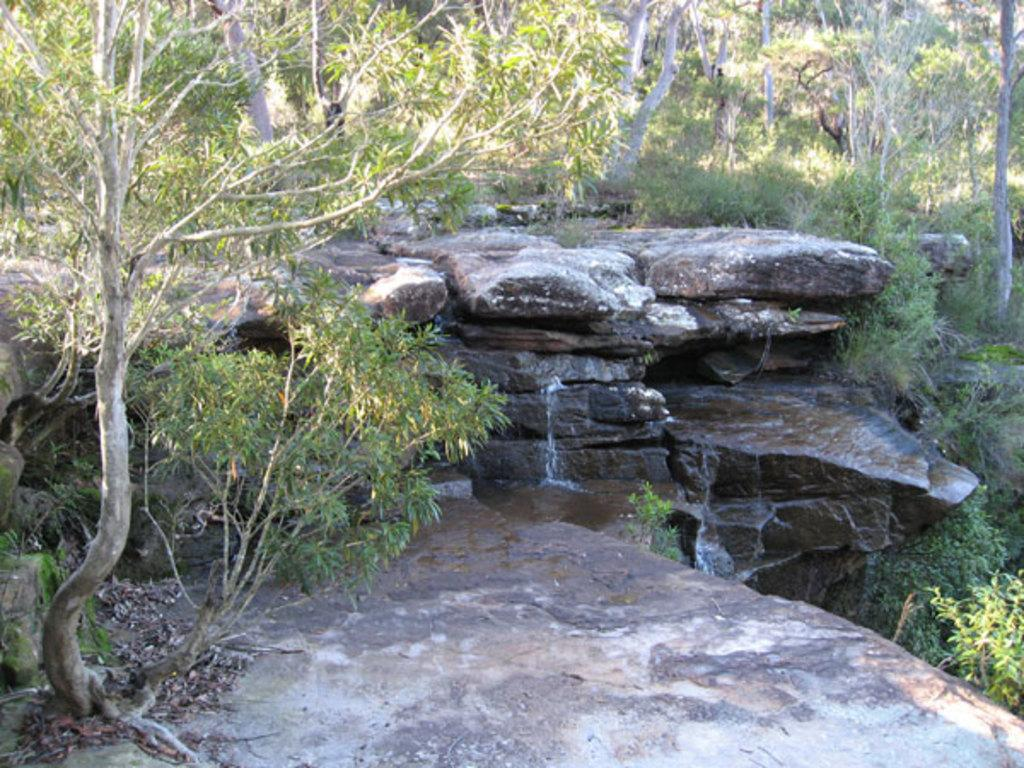What natural feature is the main subject of the image? There is a waterfall in the image. What type of vegetation can be seen in the image? There are trees in the image. What message is written on the sign in the image? There is no sign present in the image, so no message can be read. 